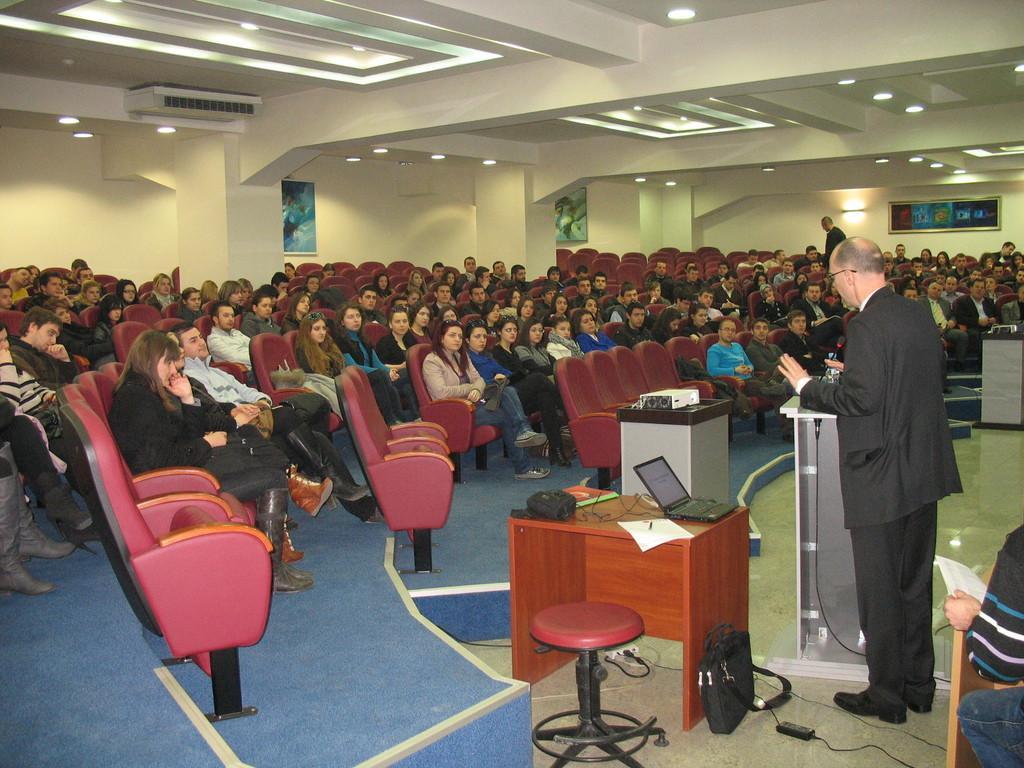Can you describe this image briefly? This is a picture of auditorium. Here we can see all the persons sitting on a chairs. we can see few photo frames over a wall. This is ceiling light. This is air conditioner. Here we can see a man standing in front of a podium and on the table we can see laptop, pen and a paper. There is a bag and chair near to the table. 